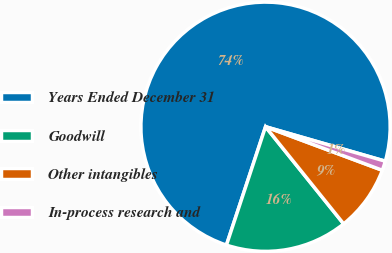Convert chart to OTSL. <chart><loc_0><loc_0><loc_500><loc_500><pie_chart><fcel>Years Ended December 31<fcel>Goodwill<fcel>Other intangibles<fcel>In-process research and<nl><fcel>74.38%<fcel>15.86%<fcel>8.54%<fcel>1.22%<nl></chart> 